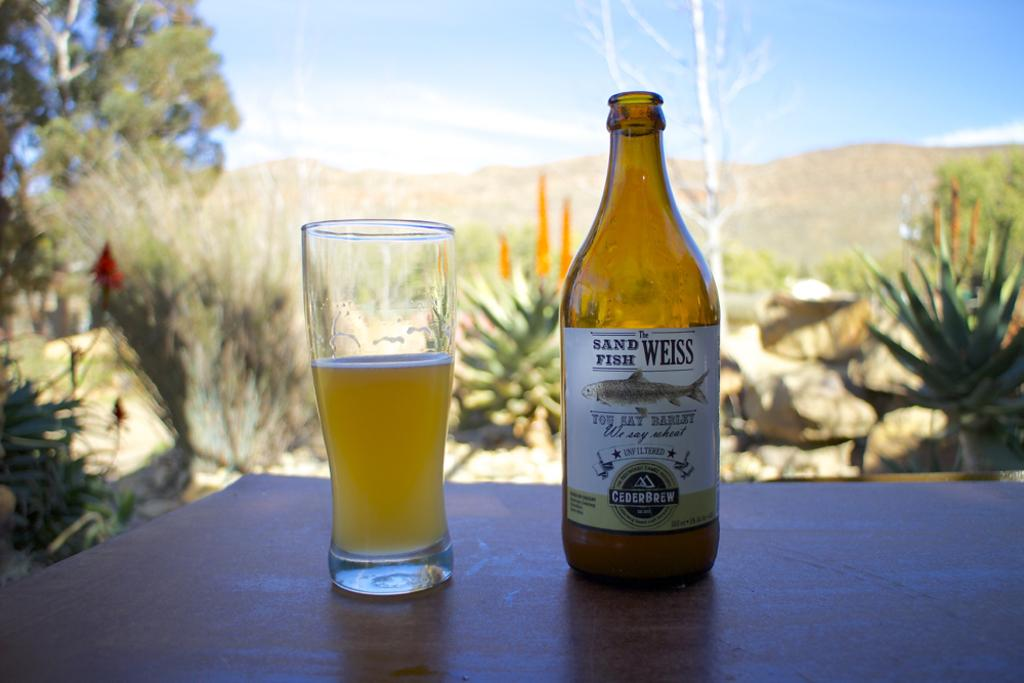<image>
Offer a succinct explanation of the picture presented. the word weiss that is on a beer bottle 